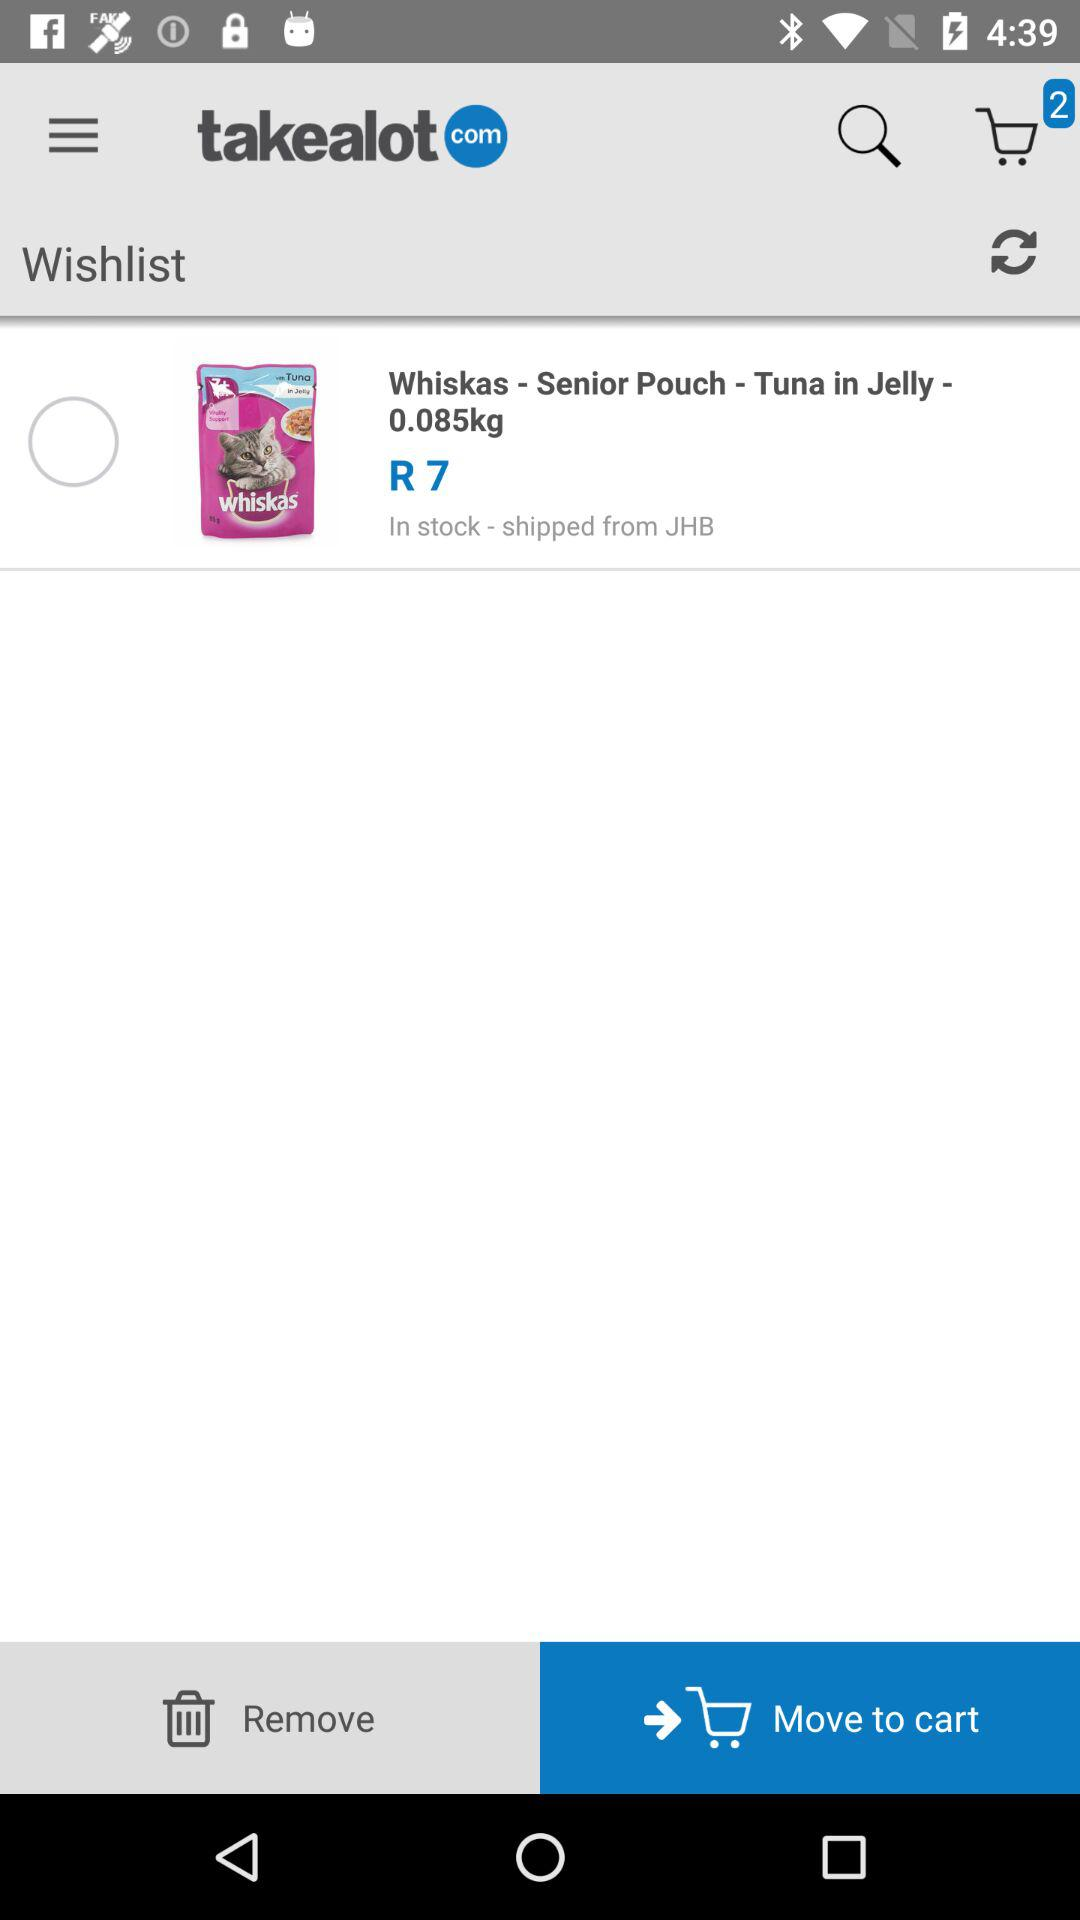How much is the Whiskas - Senior Pouch - Tuna in Jelly - 0.085kg?
Answer the question using a single word or phrase. R7 